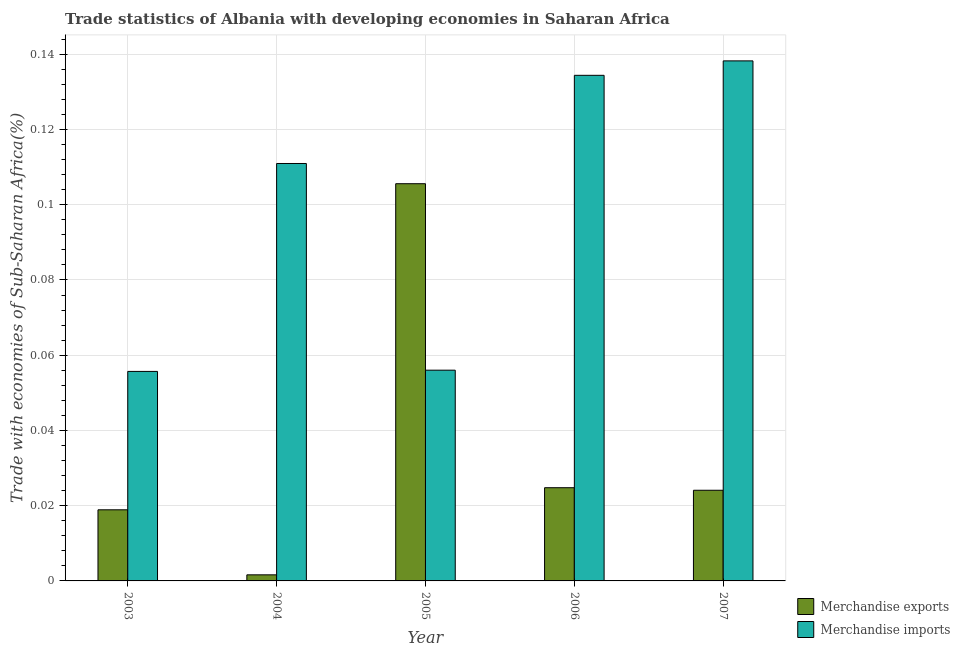Are the number of bars on each tick of the X-axis equal?
Your response must be concise. Yes. How many bars are there on the 2nd tick from the left?
Provide a succinct answer. 2. What is the label of the 4th group of bars from the left?
Your answer should be compact. 2006. In how many cases, is the number of bars for a given year not equal to the number of legend labels?
Give a very brief answer. 0. What is the merchandise exports in 2006?
Offer a terse response. 0.02. Across all years, what is the maximum merchandise imports?
Provide a short and direct response. 0.14. Across all years, what is the minimum merchandise imports?
Provide a succinct answer. 0.06. In which year was the merchandise imports maximum?
Your answer should be very brief. 2007. In which year was the merchandise imports minimum?
Give a very brief answer. 2003. What is the total merchandise exports in the graph?
Offer a terse response. 0.17. What is the difference between the merchandise imports in 2004 and that in 2005?
Offer a very short reply. 0.05. What is the difference between the merchandise exports in 2006 and the merchandise imports in 2007?
Provide a short and direct response. 0. What is the average merchandise exports per year?
Make the answer very short. 0.03. In the year 2003, what is the difference between the merchandise imports and merchandise exports?
Offer a terse response. 0. In how many years, is the merchandise imports greater than 0.068 %?
Provide a short and direct response. 3. What is the ratio of the merchandise exports in 2004 to that in 2005?
Provide a succinct answer. 0.02. Is the merchandise imports in 2003 less than that in 2007?
Your answer should be very brief. Yes. What is the difference between the highest and the second highest merchandise exports?
Keep it short and to the point. 0.08. What is the difference between the highest and the lowest merchandise exports?
Provide a succinct answer. 0.1. Is the sum of the merchandise exports in 2003 and 2004 greater than the maximum merchandise imports across all years?
Your answer should be compact. No. What does the 1st bar from the left in 2007 represents?
Your answer should be compact. Merchandise exports. What does the 1st bar from the right in 2004 represents?
Make the answer very short. Merchandise imports. How many years are there in the graph?
Keep it short and to the point. 5. Are the values on the major ticks of Y-axis written in scientific E-notation?
Give a very brief answer. No. Where does the legend appear in the graph?
Provide a succinct answer. Bottom right. How are the legend labels stacked?
Provide a short and direct response. Vertical. What is the title of the graph?
Your answer should be compact. Trade statistics of Albania with developing economies in Saharan Africa. What is the label or title of the Y-axis?
Give a very brief answer. Trade with economies of Sub-Saharan Africa(%). What is the Trade with economies of Sub-Saharan Africa(%) in Merchandise exports in 2003?
Your response must be concise. 0.02. What is the Trade with economies of Sub-Saharan Africa(%) in Merchandise imports in 2003?
Provide a succinct answer. 0.06. What is the Trade with economies of Sub-Saharan Africa(%) of Merchandise exports in 2004?
Offer a terse response. 0. What is the Trade with economies of Sub-Saharan Africa(%) of Merchandise imports in 2004?
Your response must be concise. 0.11. What is the Trade with economies of Sub-Saharan Africa(%) of Merchandise exports in 2005?
Make the answer very short. 0.11. What is the Trade with economies of Sub-Saharan Africa(%) of Merchandise imports in 2005?
Your answer should be compact. 0.06. What is the Trade with economies of Sub-Saharan Africa(%) of Merchandise exports in 2006?
Keep it short and to the point. 0.02. What is the Trade with economies of Sub-Saharan Africa(%) of Merchandise imports in 2006?
Offer a terse response. 0.13. What is the Trade with economies of Sub-Saharan Africa(%) of Merchandise exports in 2007?
Make the answer very short. 0.02. What is the Trade with economies of Sub-Saharan Africa(%) of Merchandise imports in 2007?
Offer a very short reply. 0.14. Across all years, what is the maximum Trade with economies of Sub-Saharan Africa(%) in Merchandise exports?
Your response must be concise. 0.11. Across all years, what is the maximum Trade with economies of Sub-Saharan Africa(%) of Merchandise imports?
Your response must be concise. 0.14. Across all years, what is the minimum Trade with economies of Sub-Saharan Africa(%) in Merchandise exports?
Make the answer very short. 0. Across all years, what is the minimum Trade with economies of Sub-Saharan Africa(%) in Merchandise imports?
Your response must be concise. 0.06. What is the total Trade with economies of Sub-Saharan Africa(%) of Merchandise exports in the graph?
Make the answer very short. 0.17. What is the total Trade with economies of Sub-Saharan Africa(%) of Merchandise imports in the graph?
Make the answer very short. 0.5. What is the difference between the Trade with economies of Sub-Saharan Africa(%) in Merchandise exports in 2003 and that in 2004?
Make the answer very short. 0.02. What is the difference between the Trade with economies of Sub-Saharan Africa(%) in Merchandise imports in 2003 and that in 2004?
Provide a succinct answer. -0.06. What is the difference between the Trade with economies of Sub-Saharan Africa(%) in Merchandise exports in 2003 and that in 2005?
Keep it short and to the point. -0.09. What is the difference between the Trade with economies of Sub-Saharan Africa(%) of Merchandise imports in 2003 and that in 2005?
Your answer should be compact. -0. What is the difference between the Trade with economies of Sub-Saharan Africa(%) of Merchandise exports in 2003 and that in 2006?
Give a very brief answer. -0.01. What is the difference between the Trade with economies of Sub-Saharan Africa(%) of Merchandise imports in 2003 and that in 2006?
Provide a succinct answer. -0.08. What is the difference between the Trade with economies of Sub-Saharan Africa(%) of Merchandise exports in 2003 and that in 2007?
Offer a very short reply. -0.01. What is the difference between the Trade with economies of Sub-Saharan Africa(%) of Merchandise imports in 2003 and that in 2007?
Your response must be concise. -0.08. What is the difference between the Trade with economies of Sub-Saharan Africa(%) in Merchandise exports in 2004 and that in 2005?
Your answer should be very brief. -0.1. What is the difference between the Trade with economies of Sub-Saharan Africa(%) in Merchandise imports in 2004 and that in 2005?
Ensure brevity in your answer.  0.05. What is the difference between the Trade with economies of Sub-Saharan Africa(%) of Merchandise exports in 2004 and that in 2006?
Provide a short and direct response. -0.02. What is the difference between the Trade with economies of Sub-Saharan Africa(%) of Merchandise imports in 2004 and that in 2006?
Provide a short and direct response. -0.02. What is the difference between the Trade with economies of Sub-Saharan Africa(%) in Merchandise exports in 2004 and that in 2007?
Keep it short and to the point. -0.02. What is the difference between the Trade with economies of Sub-Saharan Africa(%) in Merchandise imports in 2004 and that in 2007?
Offer a terse response. -0.03. What is the difference between the Trade with economies of Sub-Saharan Africa(%) of Merchandise exports in 2005 and that in 2006?
Provide a short and direct response. 0.08. What is the difference between the Trade with economies of Sub-Saharan Africa(%) in Merchandise imports in 2005 and that in 2006?
Your answer should be very brief. -0.08. What is the difference between the Trade with economies of Sub-Saharan Africa(%) in Merchandise exports in 2005 and that in 2007?
Keep it short and to the point. 0.08. What is the difference between the Trade with economies of Sub-Saharan Africa(%) in Merchandise imports in 2005 and that in 2007?
Ensure brevity in your answer.  -0.08. What is the difference between the Trade with economies of Sub-Saharan Africa(%) in Merchandise exports in 2006 and that in 2007?
Your answer should be very brief. 0. What is the difference between the Trade with economies of Sub-Saharan Africa(%) of Merchandise imports in 2006 and that in 2007?
Offer a very short reply. -0. What is the difference between the Trade with economies of Sub-Saharan Africa(%) of Merchandise exports in 2003 and the Trade with economies of Sub-Saharan Africa(%) of Merchandise imports in 2004?
Make the answer very short. -0.09. What is the difference between the Trade with economies of Sub-Saharan Africa(%) of Merchandise exports in 2003 and the Trade with economies of Sub-Saharan Africa(%) of Merchandise imports in 2005?
Give a very brief answer. -0.04. What is the difference between the Trade with economies of Sub-Saharan Africa(%) of Merchandise exports in 2003 and the Trade with economies of Sub-Saharan Africa(%) of Merchandise imports in 2006?
Offer a terse response. -0.12. What is the difference between the Trade with economies of Sub-Saharan Africa(%) in Merchandise exports in 2003 and the Trade with economies of Sub-Saharan Africa(%) in Merchandise imports in 2007?
Keep it short and to the point. -0.12. What is the difference between the Trade with economies of Sub-Saharan Africa(%) in Merchandise exports in 2004 and the Trade with economies of Sub-Saharan Africa(%) in Merchandise imports in 2005?
Make the answer very short. -0.05. What is the difference between the Trade with economies of Sub-Saharan Africa(%) in Merchandise exports in 2004 and the Trade with economies of Sub-Saharan Africa(%) in Merchandise imports in 2006?
Offer a very short reply. -0.13. What is the difference between the Trade with economies of Sub-Saharan Africa(%) in Merchandise exports in 2004 and the Trade with economies of Sub-Saharan Africa(%) in Merchandise imports in 2007?
Make the answer very short. -0.14. What is the difference between the Trade with economies of Sub-Saharan Africa(%) of Merchandise exports in 2005 and the Trade with economies of Sub-Saharan Africa(%) of Merchandise imports in 2006?
Your answer should be very brief. -0.03. What is the difference between the Trade with economies of Sub-Saharan Africa(%) in Merchandise exports in 2005 and the Trade with economies of Sub-Saharan Africa(%) in Merchandise imports in 2007?
Make the answer very short. -0.03. What is the difference between the Trade with economies of Sub-Saharan Africa(%) of Merchandise exports in 2006 and the Trade with economies of Sub-Saharan Africa(%) of Merchandise imports in 2007?
Your response must be concise. -0.11. What is the average Trade with economies of Sub-Saharan Africa(%) in Merchandise exports per year?
Your answer should be very brief. 0.04. What is the average Trade with economies of Sub-Saharan Africa(%) of Merchandise imports per year?
Keep it short and to the point. 0.1. In the year 2003, what is the difference between the Trade with economies of Sub-Saharan Africa(%) in Merchandise exports and Trade with economies of Sub-Saharan Africa(%) in Merchandise imports?
Your answer should be compact. -0.04. In the year 2004, what is the difference between the Trade with economies of Sub-Saharan Africa(%) of Merchandise exports and Trade with economies of Sub-Saharan Africa(%) of Merchandise imports?
Keep it short and to the point. -0.11. In the year 2005, what is the difference between the Trade with economies of Sub-Saharan Africa(%) in Merchandise exports and Trade with economies of Sub-Saharan Africa(%) in Merchandise imports?
Keep it short and to the point. 0.05. In the year 2006, what is the difference between the Trade with economies of Sub-Saharan Africa(%) in Merchandise exports and Trade with economies of Sub-Saharan Africa(%) in Merchandise imports?
Provide a succinct answer. -0.11. In the year 2007, what is the difference between the Trade with economies of Sub-Saharan Africa(%) of Merchandise exports and Trade with economies of Sub-Saharan Africa(%) of Merchandise imports?
Offer a terse response. -0.11. What is the ratio of the Trade with economies of Sub-Saharan Africa(%) of Merchandise exports in 2003 to that in 2004?
Provide a short and direct response. 11.7. What is the ratio of the Trade with economies of Sub-Saharan Africa(%) in Merchandise imports in 2003 to that in 2004?
Offer a terse response. 0.5. What is the ratio of the Trade with economies of Sub-Saharan Africa(%) in Merchandise exports in 2003 to that in 2005?
Your answer should be compact. 0.18. What is the ratio of the Trade with economies of Sub-Saharan Africa(%) of Merchandise imports in 2003 to that in 2005?
Give a very brief answer. 0.99. What is the ratio of the Trade with economies of Sub-Saharan Africa(%) in Merchandise exports in 2003 to that in 2006?
Ensure brevity in your answer.  0.76. What is the ratio of the Trade with economies of Sub-Saharan Africa(%) in Merchandise imports in 2003 to that in 2006?
Keep it short and to the point. 0.41. What is the ratio of the Trade with economies of Sub-Saharan Africa(%) of Merchandise exports in 2003 to that in 2007?
Make the answer very short. 0.78. What is the ratio of the Trade with economies of Sub-Saharan Africa(%) of Merchandise imports in 2003 to that in 2007?
Ensure brevity in your answer.  0.4. What is the ratio of the Trade with economies of Sub-Saharan Africa(%) in Merchandise exports in 2004 to that in 2005?
Provide a short and direct response. 0.02. What is the ratio of the Trade with economies of Sub-Saharan Africa(%) of Merchandise imports in 2004 to that in 2005?
Your response must be concise. 1.98. What is the ratio of the Trade with economies of Sub-Saharan Africa(%) in Merchandise exports in 2004 to that in 2006?
Provide a short and direct response. 0.07. What is the ratio of the Trade with economies of Sub-Saharan Africa(%) of Merchandise imports in 2004 to that in 2006?
Offer a very short reply. 0.83. What is the ratio of the Trade with economies of Sub-Saharan Africa(%) of Merchandise exports in 2004 to that in 2007?
Your answer should be very brief. 0.07. What is the ratio of the Trade with economies of Sub-Saharan Africa(%) in Merchandise imports in 2004 to that in 2007?
Your response must be concise. 0.8. What is the ratio of the Trade with economies of Sub-Saharan Africa(%) of Merchandise exports in 2005 to that in 2006?
Offer a terse response. 4.26. What is the ratio of the Trade with economies of Sub-Saharan Africa(%) of Merchandise imports in 2005 to that in 2006?
Offer a terse response. 0.42. What is the ratio of the Trade with economies of Sub-Saharan Africa(%) of Merchandise exports in 2005 to that in 2007?
Your response must be concise. 4.38. What is the ratio of the Trade with economies of Sub-Saharan Africa(%) of Merchandise imports in 2005 to that in 2007?
Ensure brevity in your answer.  0.41. What is the ratio of the Trade with economies of Sub-Saharan Africa(%) of Merchandise exports in 2006 to that in 2007?
Make the answer very short. 1.03. What is the ratio of the Trade with economies of Sub-Saharan Africa(%) in Merchandise imports in 2006 to that in 2007?
Ensure brevity in your answer.  0.97. What is the difference between the highest and the second highest Trade with economies of Sub-Saharan Africa(%) in Merchandise exports?
Keep it short and to the point. 0.08. What is the difference between the highest and the second highest Trade with economies of Sub-Saharan Africa(%) of Merchandise imports?
Ensure brevity in your answer.  0. What is the difference between the highest and the lowest Trade with economies of Sub-Saharan Africa(%) of Merchandise exports?
Offer a terse response. 0.1. What is the difference between the highest and the lowest Trade with economies of Sub-Saharan Africa(%) of Merchandise imports?
Ensure brevity in your answer.  0.08. 